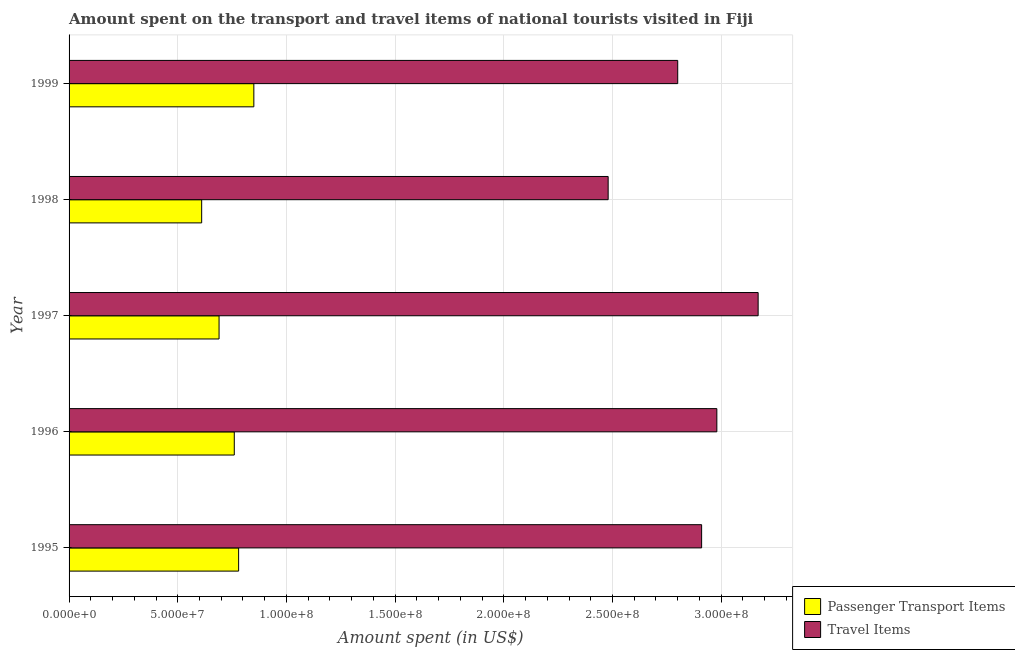How many groups of bars are there?
Offer a very short reply. 5. Are the number of bars per tick equal to the number of legend labels?
Give a very brief answer. Yes. Are the number of bars on each tick of the Y-axis equal?
Your answer should be compact. Yes. How many bars are there on the 3rd tick from the bottom?
Give a very brief answer. 2. What is the label of the 2nd group of bars from the top?
Your answer should be very brief. 1998. What is the amount spent in travel items in 1995?
Keep it short and to the point. 2.91e+08. Across all years, what is the maximum amount spent in travel items?
Offer a very short reply. 3.17e+08. Across all years, what is the minimum amount spent in travel items?
Your response must be concise. 2.48e+08. In which year was the amount spent on passenger transport items maximum?
Your answer should be very brief. 1999. In which year was the amount spent in travel items minimum?
Provide a short and direct response. 1998. What is the total amount spent on passenger transport items in the graph?
Provide a succinct answer. 3.69e+08. What is the difference between the amount spent in travel items in 1997 and that in 1999?
Offer a terse response. 3.70e+07. What is the difference between the amount spent in travel items in 1997 and the amount spent on passenger transport items in 1995?
Offer a terse response. 2.39e+08. What is the average amount spent in travel items per year?
Your answer should be very brief. 2.87e+08. In the year 1999, what is the difference between the amount spent on passenger transport items and amount spent in travel items?
Your response must be concise. -1.95e+08. What is the ratio of the amount spent on passenger transport items in 1995 to that in 1997?
Your response must be concise. 1.13. Is the amount spent on passenger transport items in 1996 less than that in 1999?
Offer a terse response. Yes. What is the difference between the highest and the second highest amount spent in travel items?
Offer a terse response. 1.90e+07. What is the difference between the highest and the lowest amount spent in travel items?
Offer a terse response. 6.90e+07. What does the 2nd bar from the top in 1999 represents?
Give a very brief answer. Passenger Transport Items. What does the 2nd bar from the bottom in 1999 represents?
Make the answer very short. Travel Items. How many years are there in the graph?
Provide a succinct answer. 5. What is the difference between two consecutive major ticks on the X-axis?
Make the answer very short. 5.00e+07. Does the graph contain any zero values?
Keep it short and to the point. No. How many legend labels are there?
Your response must be concise. 2. How are the legend labels stacked?
Make the answer very short. Vertical. What is the title of the graph?
Ensure brevity in your answer.  Amount spent on the transport and travel items of national tourists visited in Fiji. What is the label or title of the X-axis?
Your response must be concise. Amount spent (in US$). What is the label or title of the Y-axis?
Provide a short and direct response. Year. What is the Amount spent (in US$) in Passenger Transport Items in 1995?
Give a very brief answer. 7.80e+07. What is the Amount spent (in US$) in Travel Items in 1995?
Give a very brief answer. 2.91e+08. What is the Amount spent (in US$) in Passenger Transport Items in 1996?
Offer a very short reply. 7.60e+07. What is the Amount spent (in US$) in Travel Items in 1996?
Keep it short and to the point. 2.98e+08. What is the Amount spent (in US$) of Passenger Transport Items in 1997?
Offer a very short reply. 6.90e+07. What is the Amount spent (in US$) in Travel Items in 1997?
Provide a short and direct response. 3.17e+08. What is the Amount spent (in US$) of Passenger Transport Items in 1998?
Your answer should be very brief. 6.10e+07. What is the Amount spent (in US$) of Travel Items in 1998?
Provide a short and direct response. 2.48e+08. What is the Amount spent (in US$) of Passenger Transport Items in 1999?
Ensure brevity in your answer.  8.50e+07. What is the Amount spent (in US$) of Travel Items in 1999?
Provide a succinct answer. 2.80e+08. Across all years, what is the maximum Amount spent (in US$) of Passenger Transport Items?
Give a very brief answer. 8.50e+07. Across all years, what is the maximum Amount spent (in US$) of Travel Items?
Keep it short and to the point. 3.17e+08. Across all years, what is the minimum Amount spent (in US$) of Passenger Transport Items?
Give a very brief answer. 6.10e+07. Across all years, what is the minimum Amount spent (in US$) in Travel Items?
Make the answer very short. 2.48e+08. What is the total Amount spent (in US$) in Passenger Transport Items in the graph?
Keep it short and to the point. 3.69e+08. What is the total Amount spent (in US$) in Travel Items in the graph?
Your answer should be very brief. 1.43e+09. What is the difference between the Amount spent (in US$) in Passenger Transport Items in 1995 and that in 1996?
Provide a succinct answer. 2.00e+06. What is the difference between the Amount spent (in US$) in Travel Items in 1995 and that in 1996?
Offer a terse response. -7.00e+06. What is the difference between the Amount spent (in US$) in Passenger Transport Items in 1995 and that in 1997?
Offer a terse response. 9.00e+06. What is the difference between the Amount spent (in US$) in Travel Items in 1995 and that in 1997?
Offer a terse response. -2.60e+07. What is the difference between the Amount spent (in US$) of Passenger Transport Items in 1995 and that in 1998?
Your answer should be very brief. 1.70e+07. What is the difference between the Amount spent (in US$) in Travel Items in 1995 and that in 1998?
Your answer should be very brief. 4.30e+07. What is the difference between the Amount spent (in US$) in Passenger Transport Items in 1995 and that in 1999?
Offer a very short reply. -7.00e+06. What is the difference between the Amount spent (in US$) of Travel Items in 1995 and that in 1999?
Your answer should be compact. 1.10e+07. What is the difference between the Amount spent (in US$) of Travel Items in 1996 and that in 1997?
Your answer should be very brief. -1.90e+07. What is the difference between the Amount spent (in US$) in Passenger Transport Items in 1996 and that in 1998?
Provide a succinct answer. 1.50e+07. What is the difference between the Amount spent (in US$) in Travel Items in 1996 and that in 1998?
Ensure brevity in your answer.  5.00e+07. What is the difference between the Amount spent (in US$) of Passenger Transport Items in 1996 and that in 1999?
Provide a succinct answer. -9.00e+06. What is the difference between the Amount spent (in US$) in Travel Items in 1996 and that in 1999?
Your answer should be very brief. 1.80e+07. What is the difference between the Amount spent (in US$) in Travel Items in 1997 and that in 1998?
Your response must be concise. 6.90e+07. What is the difference between the Amount spent (in US$) of Passenger Transport Items in 1997 and that in 1999?
Your answer should be very brief. -1.60e+07. What is the difference between the Amount spent (in US$) in Travel Items in 1997 and that in 1999?
Keep it short and to the point. 3.70e+07. What is the difference between the Amount spent (in US$) in Passenger Transport Items in 1998 and that in 1999?
Your answer should be compact. -2.40e+07. What is the difference between the Amount spent (in US$) in Travel Items in 1998 and that in 1999?
Offer a very short reply. -3.20e+07. What is the difference between the Amount spent (in US$) of Passenger Transport Items in 1995 and the Amount spent (in US$) of Travel Items in 1996?
Your response must be concise. -2.20e+08. What is the difference between the Amount spent (in US$) of Passenger Transport Items in 1995 and the Amount spent (in US$) of Travel Items in 1997?
Your response must be concise. -2.39e+08. What is the difference between the Amount spent (in US$) of Passenger Transport Items in 1995 and the Amount spent (in US$) of Travel Items in 1998?
Offer a very short reply. -1.70e+08. What is the difference between the Amount spent (in US$) of Passenger Transport Items in 1995 and the Amount spent (in US$) of Travel Items in 1999?
Provide a short and direct response. -2.02e+08. What is the difference between the Amount spent (in US$) in Passenger Transport Items in 1996 and the Amount spent (in US$) in Travel Items in 1997?
Provide a short and direct response. -2.41e+08. What is the difference between the Amount spent (in US$) in Passenger Transport Items in 1996 and the Amount spent (in US$) in Travel Items in 1998?
Make the answer very short. -1.72e+08. What is the difference between the Amount spent (in US$) of Passenger Transport Items in 1996 and the Amount spent (in US$) of Travel Items in 1999?
Offer a terse response. -2.04e+08. What is the difference between the Amount spent (in US$) of Passenger Transport Items in 1997 and the Amount spent (in US$) of Travel Items in 1998?
Offer a terse response. -1.79e+08. What is the difference between the Amount spent (in US$) in Passenger Transport Items in 1997 and the Amount spent (in US$) in Travel Items in 1999?
Offer a terse response. -2.11e+08. What is the difference between the Amount spent (in US$) in Passenger Transport Items in 1998 and the Amount spent (in US$) in Travel Items in 1999?
Give a very brief answer. -2.19e+08. What is the average Amount spent (in US$) in Passenger Transport Items per year?
Provide a succinct answer. 7.38e+07. What is the average Amount spent (in US$) of Travel Items per year?
Your answer should be compact. 2.87e+08. In the year 1995, what is the difference between the Amount spent (in US$) in Passenger Transport Items and Amount spent (in US$) in Travel Items?
Make the answer very short. -2.13e+08. In the year 1996, what is the difference between the Amount spent (in US$) in Passenger Transport Items and Amount spent (in US$) in Travel Items?
Your response must be concise. -2.22e+08. In the year 1997, what is the difference between the Amount spent (in US$) in Passenger Transport Items and Amount spent (in US$) in Travel Items?
Your answer should be very brief. -2.48e+08. In the year 1998, what is the difference between the Amount spent (in US$) in Passenger Transport Items and Amount spent (in US$) in Travel Items?
Your answer should be compact. -1.87e+08. In the year 1999, what is the difference between the Amount spent (in US$) in Passenger Transport Items and Amount spent (in US$) in Travel Items?
Your answer should be compact. -1.95e+08. What is the ratio of the Amount spent (in US$) in Passenger Transport Items in 1995 to that in 1996?
Provide a succinct answer. 1.03. What is the ratio of the Amount spent (in US$) in Travel Items in 1995 to that in 1996?
Keep it short and to the point. 0.98. What is the ratio of the Amount spent (in US$) in Passenger Transport Items in 1995 to that in 1997?
Your response must be concise. 1.13. What is the ratio of the Amount spent (in US$) of Travel Items in 1995 to that in 1997?
Offer a terse response. 0.92. What is the ratio of the Amount spent (in US$) of Passenger Transport Items in 1995 to that in 1998?
Offer a very short reply. 1.28. What is the ratio of the Amount spent (in US$) of Travel Items in 1995 to that in 1998?
Offer a very short reply. 1.17. What is the ratio of the Amount spent (in US$) in Passenger Transport Items in 1995 to that in 1999?
Your answer should be very brief. 0.92. What is the ratio of the Amount spent (in US$) of Travel Items in 1995 to that in 1999?
Offer a terse response. 1.04. What is the ratio of the Amount spent (in US$) in Passenger Transport Items in 1996 to that in 1997?
Provide a succinct answer. 1.1. What is the ratio of the Amount spent (in US$) of Travel Items in 1996 to that in 1997?
Your response must be concise. 0.94. What is the ratio of the Amount spent (in US$) of Passenger Transport Items in 1996 to that in 1998?
Keep it short and to the point. 1.25. What is the ratio of the Amount spent (in US$) in Travel Items in 1996 to that in 1998?
Ensure brevity in your answer.  1.2. What is the ratio of the Amount spent (in US$) in Passenger Transport Items in 1996 to that in 1999?
Ensure brevity in your answer.  0.89. What is the ratio of the Amount spent (in US$) of Travel Items in 1996 to that in 1999?
Your answer should be very brief. 1.06. What is the ratio of the Amount spent (in US$) of Passenger Transport Items in 1997 to that in 1998?
Give a very brief answer. 1.13. What is the ratio of the Amount spent (in US$) of Travel Items in 1997 to that in 1998?
Ensure brevity in your answer.  1.28. What is the ratio of the Amount spent (in US$) of Passenger Transport Items in 1997 to that in 1999?
Offer a terse response. 0.81. What is the ratio of the Amount spent (in US$) of Travel Items in 1997 to that in 1999?
Ensure brevity in your answer.  1.13. What is the ratio of the Amount spent (in US$) of Passenger Transport Items in 1998 to that in 1999?
Your answer should be very brief. 0.72. What is the ratio of the Amount spent (in US$) of Travel Items in 1998 to that in 1999?
Your answer should be very brief. 0.89. What is the difference between the highest and the second highest Amount spent (in US$) in Passenger Transport Items?
Keep it short and to the point. 7.00e+06. What is the difference between the highest and the second highest Amount spent (in US$) in Travel Items?
Give a very brief answer. 1.90e+07. What is the difference between the highest and the lowest Amount spent (in US$) in Passenger Transport Items?
Offer a very short reply. 2.40e+07. What is the difference between the highest and the lowest Amount spent (in US$) in Travel Items?
Ensure brevity in your answer.  6.90e+07. 